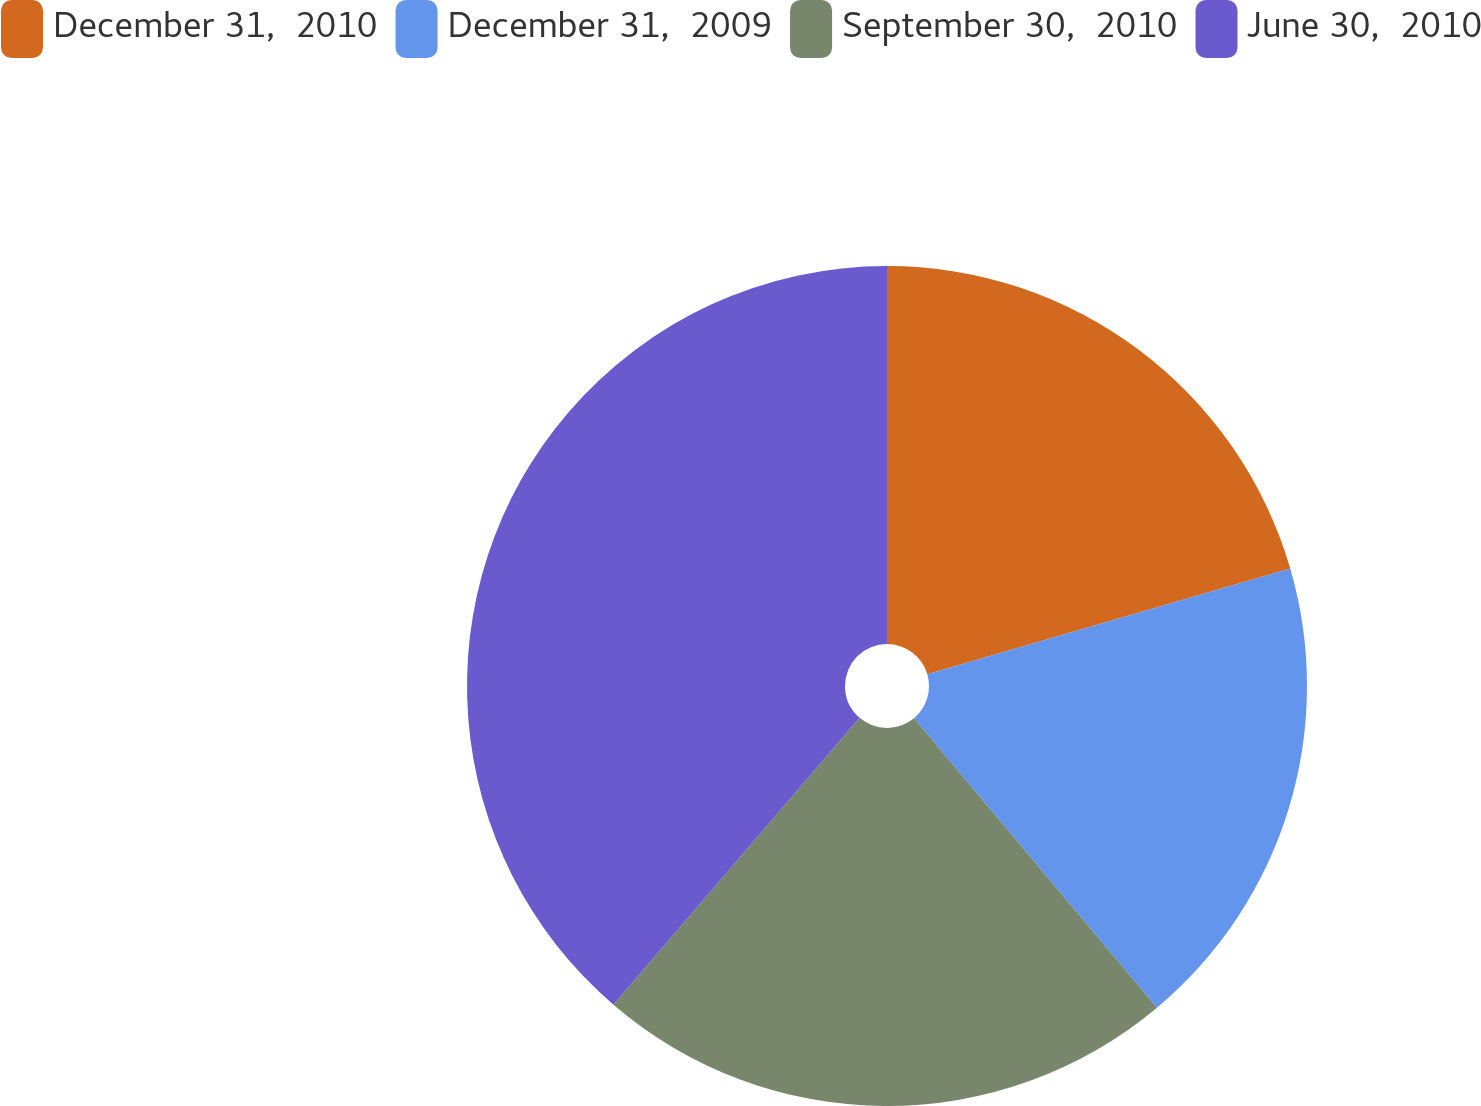Convert chart. <chart><loc_0><loc_0><loc_500><loc_500><pie_chart><fcel>December 31,  2010<fcel>December 31,  2009<fcel>September 30,  2010<fcel>June 30,  2010<nl><fcel>20.49%<fcel>18.4%<fcel>22.4%<fcel>38.71%<nl></chart> 